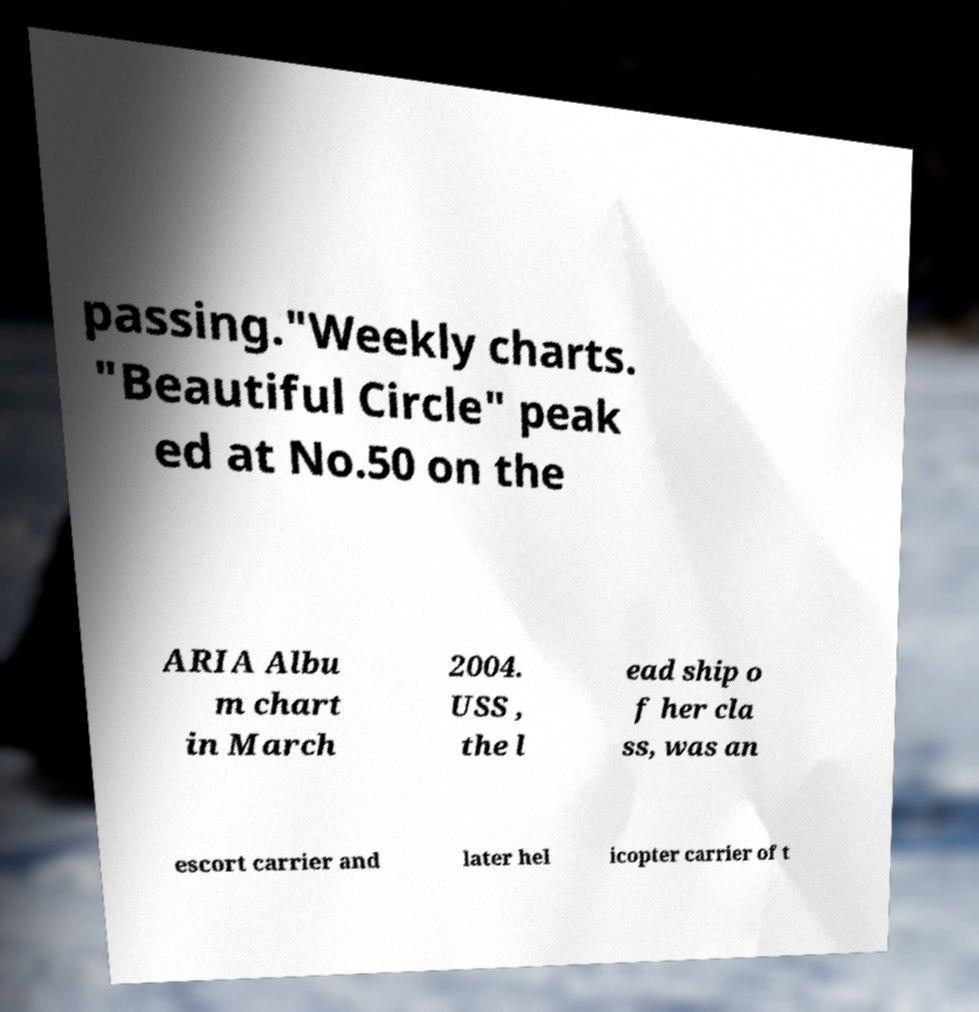Can you read and provide the text displayed in the image?This photo seems to have some interesting text. Can you extract and type it out for me? passing."Weekly charts. "Beautiful Circle" peak ed at No.50 on the ARIA Albu m chart in March 2004. USS , the l ead ship o f her cla ss, was an escort carrier and later hel icopter carrier of t 